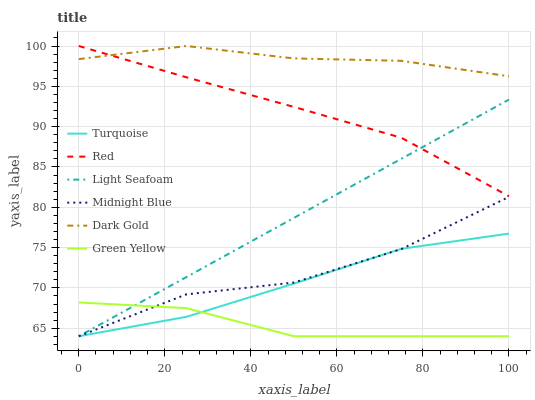Does Green Yellow have the minimum area under the curve?
Answer yes or no. Yes. Does Dark Gold have the maximum area under the curve?
Answer yes or no. Yes. Does Light Seafoam have the minimum area under the curve?
Answer yes or no. No. Does Light Seafoam have the maximum area under the curve?
Answer yes or no. No. Is Light Seafoam the smoothest?
Answer yes or no. Yes. Is Midnight Blue the roughest?
Answer yes or no. Yes. Is Midnight Blue the smoothest?
Answer yes or no. No. Is Light Seafoam the roughest?
Answer yes or no. No. Does Turquoise have the lowest value?
Answer yes or no. Yes. Does Dark Gold have the lowest value?
Answer yes or no. No. Does Red have the highest value?
Answer yes or no. Yes. Does Light Seafoam have the highest value?
Answer yes or no. No. Is Turquoise less than Dark Gold?
Answer yes or no. Yes. Is Dark Gold greater than Turquoise?
Answer yes or no. Yes. Does Light Seafoam intersect Red?
Answer yes or no. Yes. Is Light Seafoam less than Red?
Answer yes or no. No. Is Light Seafoam greater than Red?
Answer yes or no. No. Does Turquoise intersect Dark Gold?
Answer yes or no. No. 